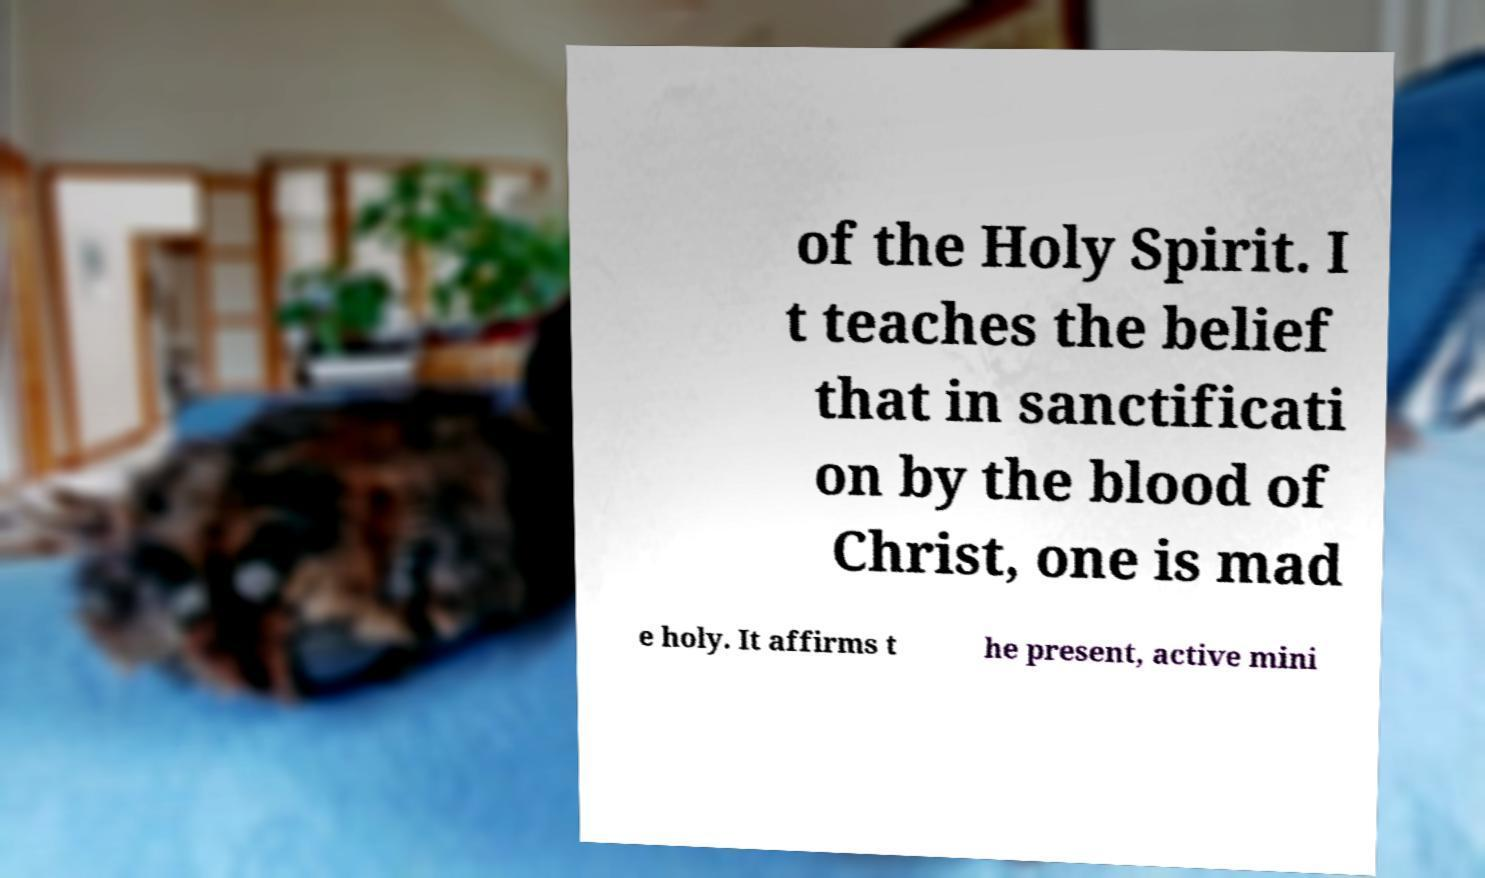Could you assist in decoding the text presented in this image and type it out clearly? of the Holy Spirit. I t teaches the belief that in sanctificati on by the blood of Christ, one is mad e holy. It affirms t he present, active mini 